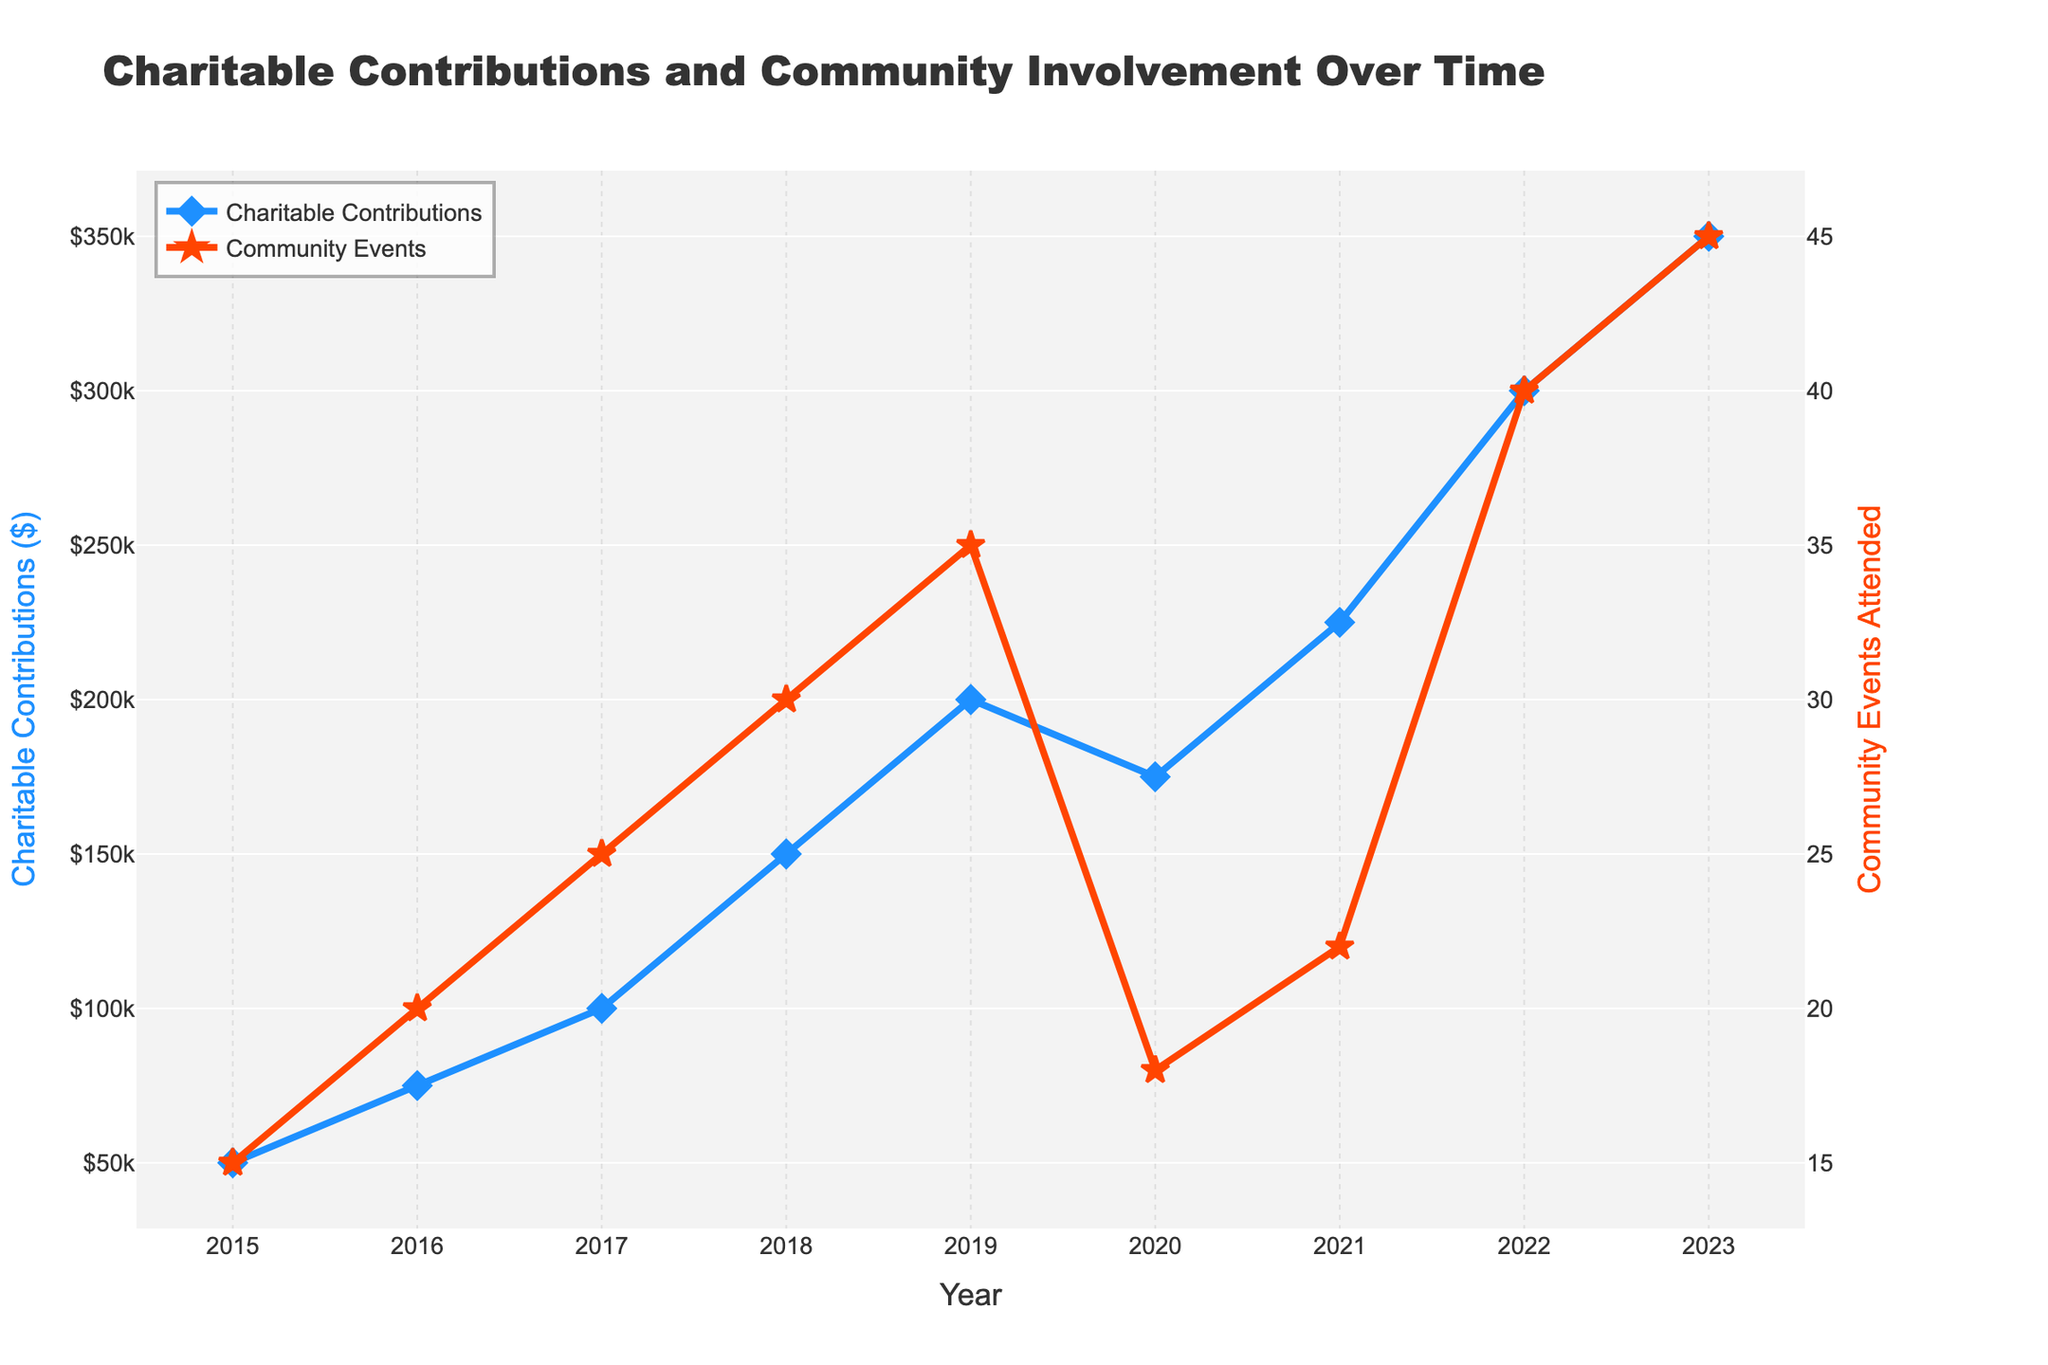What is the general trend in Charitable Contributions from 2015 to 2023? The general trend in Charitable Contributions is consistently increasing from $50,000 in 2015 to $350,000 in 2023.
Answer: Increasing How many community events were attended in 2020? Referring to the figure, in 2020, the Community Events Attended is 18.
Answer: 18 What is the difference in Charitable Contributions between the years 2019 and 2020? The Charitable Contributions in 2019 are $200,000 and in 2020 are $175,000. The difference is $200,000 - $175,000 = $25,000.
Answer: $25,000 In which year was the number of Community Events Attended highest? Referring to the figure, the highest number of Community Events Attended, which is 45, occurred in the year 2023.
Answer: 2023 Compare the Charitable Contributions between 2018 and 2022. Which year had higher contributions and by how much? In 2018, the contributions were $150,000, and in 2022, they were $300,000. 2022 had higher contributions by $300,000 - $150,000 = $150,000.
Answer: 2022 by $150,000 Please describe the visual difference between the trend lines for Charitable Contributions and Community Events Attended. The Charitable Contributions line is blue with diamond markers, showing a general upward trend. The Community Events Attended line is red with star markers, also trending upward but with a noticeable dip in 2020.
Answer: Blue line with diamonds and a red line with stars If you calculate the average Charitable Contributions over the period from 2015 to 2023, what would it be? The total contributions from 2015 to 2023 are $50,000 + $75,000 + $100,000 + $150,000 + $200,000 + $175,000 + $225,000 + $300,000 + $350,000 = $1,625,000. Dividing by 9 years, the average is $1,625,000 / 9 ≈ $180,556.
Answer: $180,556 Between which consecutive years was the largest increase in community events attended observed? The largest increase occurs between 2022 and 2023, where the number of events attended increased from 40 to 45, an increase of 5 events.
Answer: 2022 to 2023 What is the total number of Community Events attended over the entire period? Summing the values over the years 2015 to 2023, the total is 15 + 20 + 25 + 30 + 35 + 18 + 22 + 40 + 45 = 250 events.
Answer: 250 What is the ratio of Charitable Contributions to Community Events Attended in 2021? In 2021, Charitable Contributions are $225,000 and Community Events are 22. The ratio is $225,000 / 22 ≈ $10,227 per event.
Answer: $10,227 per event 